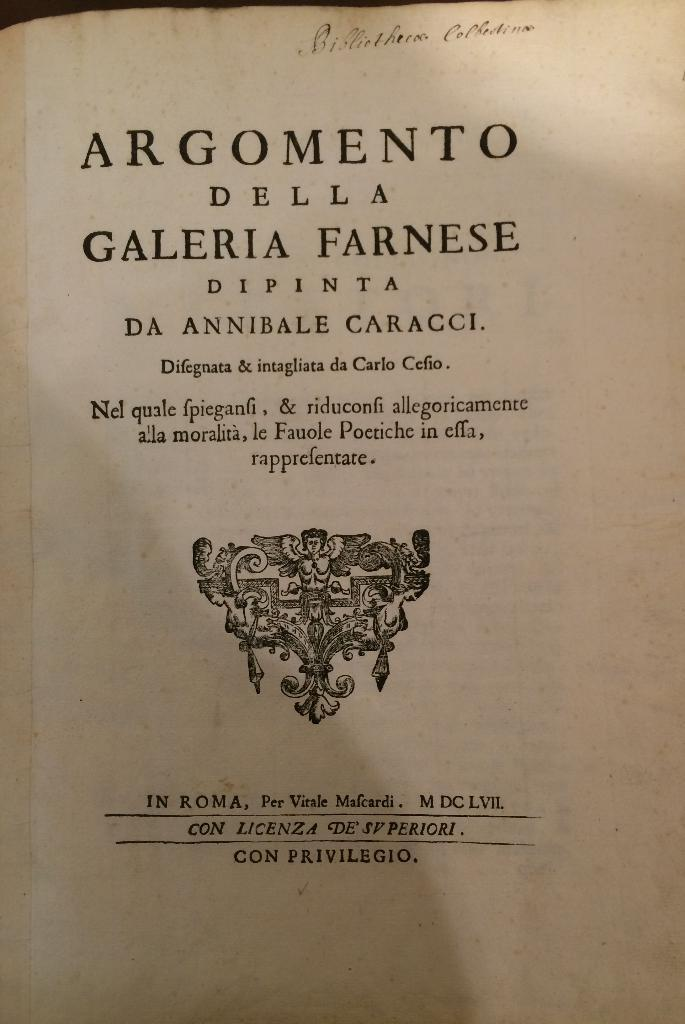<image>
Summarize the visual content of the image. An old book that says Argomento Della Galeria Farnese Dipinta Da Annibale Caracci. 